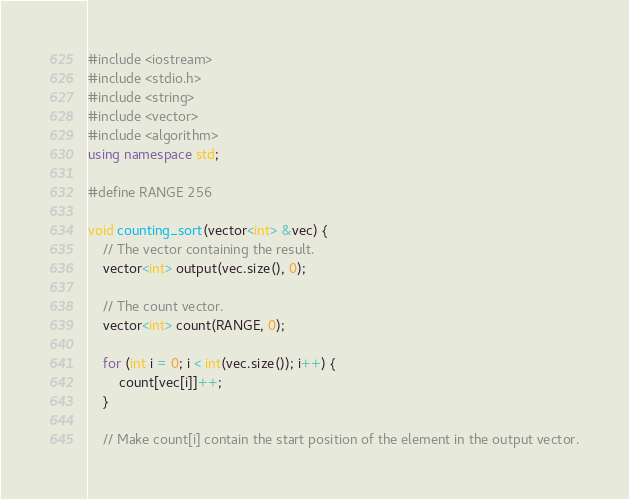<code> <loc_0><loc_0><loc_500><loc_500><_C++_>#include <iostream>
#include <stdio.h>
#include <string>
#include <vector>
#include <algorithm>
using namespace std;

#define RANGE 256

void counting_sort(vector<int> &vec) {
	// The vector containing the result.
	vector<int> output(vec.size(), 0);
	
	// The count vector.
	vector<int> count(RANGE, 0);
	
	for (int i = 0; i < int(vec.size()); i++) {
		count[vec[i]]++;
	}
	
	// Make count[i] contain the start position of the element in the output vector.</code> 